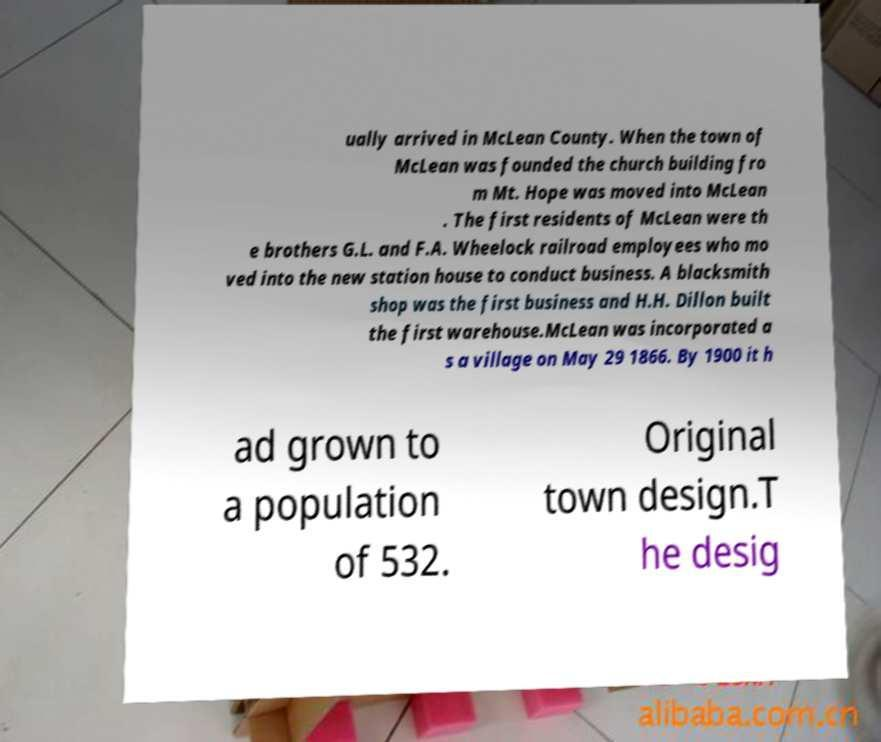Could you assist in decoding the text presented in this image and type it out clearly? ually arrived in McLean County. When the town of McLean was founded the church building fro m Mt. Hope was moved into McLean . The first residents of McLean were th e brothers G.L. and F.A. Wheelock railroad employees who mo ved into the new station house to conduct business. A blacksmith shop was the first business and H.H. Dillon built the first warehouse.McLean was incorporated a s a village on May 29 1866. By 1900 it h ad grown to a population of 532. Original town design.T he desig 